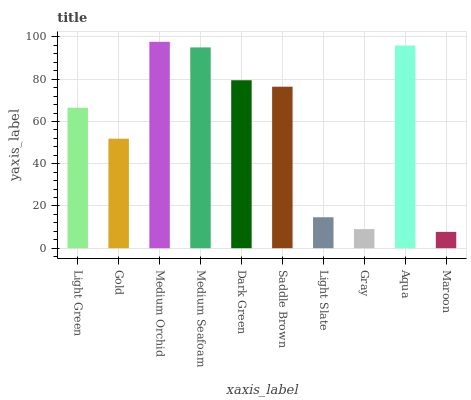Is Gold the minimum?
Answer yes or no. No. Is Gold the maximum?
Answer yes or no. No. Is Light Green greater than Gold?
Answer yes or no. Yes. Is Gold less than Light Green?
Answer yes or no. Yes. Is Gold greater than Light Green?
Answer yes or no. No. Is Light Green less than Gold?
Answer yes or no. No. Is Saddle Brown the high median?
Answer yes or no. Yes. Is Light Green the low median?
Answer yes or no. Yes. Is Medium Orchid the high median?
Answer yes or no. No. Is Maroon the low median?
Answer yes or no. No. 